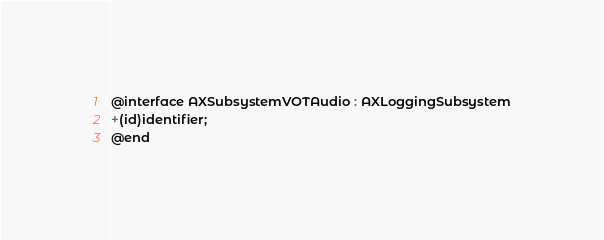<code> <loc_0><loc_0><loc_500><loc_500><_C_>
@interface AXSubsystemVOTAudio : AXLoggingSubsystem
+(id)identifier;
@end

</code> 